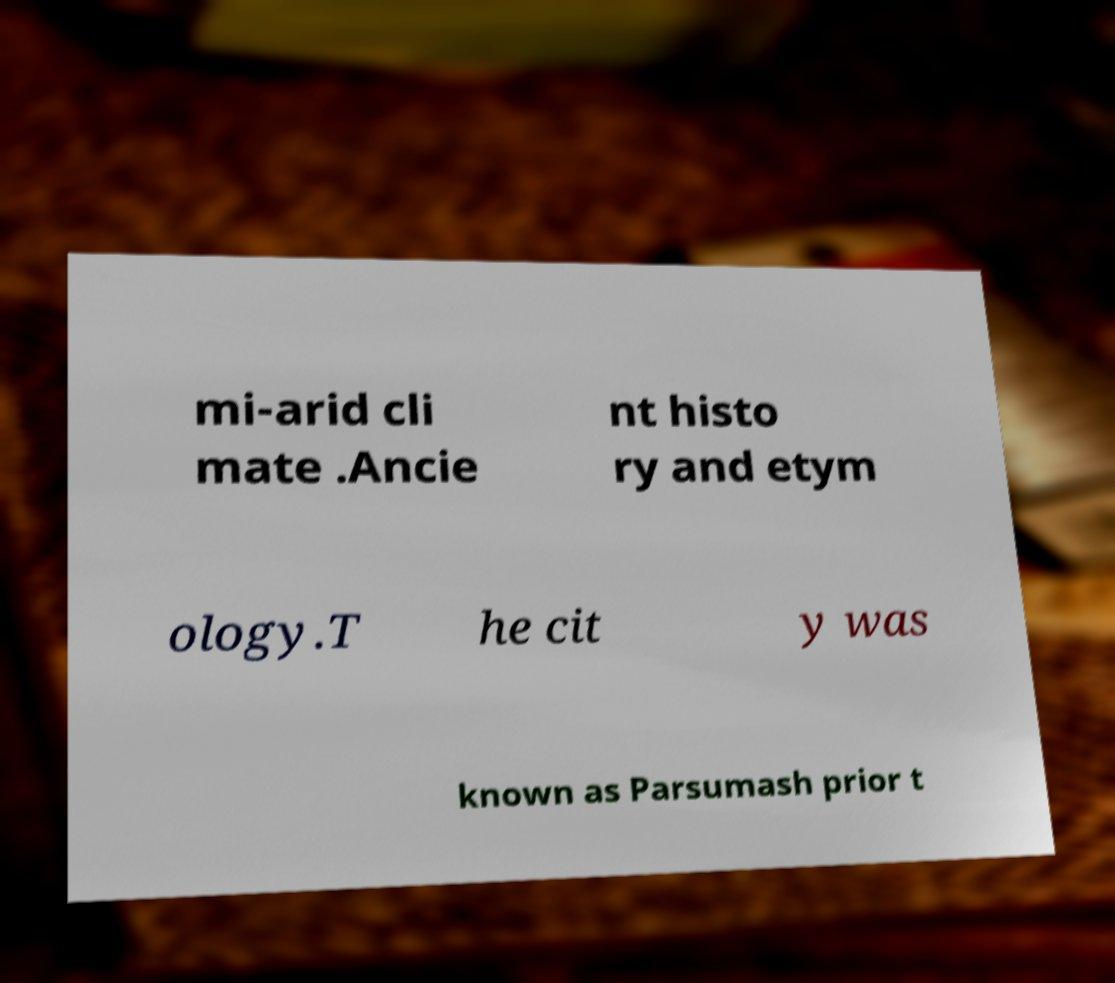There's text embedded in this image that I need extracted. Can you transcribe it verbatim? mi-arid cli mate .Ancie nt histo ry and etym ology.T he cit y was known as Parsumash prior t 